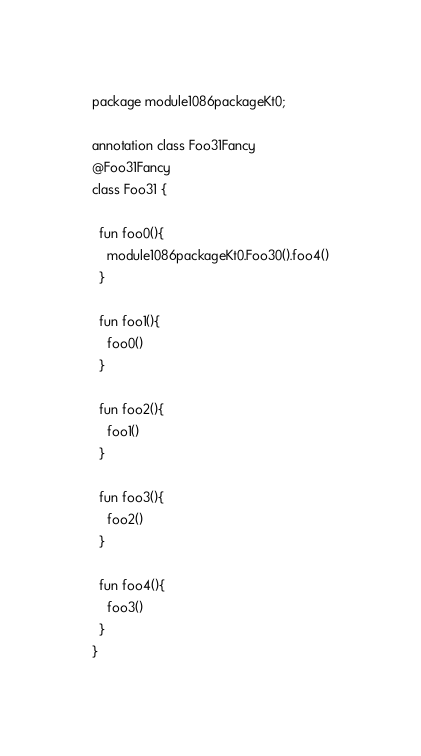<code> <loc_0><loc_0><loc_500><loc_500><_Kotlin_>package module1086packageKt0;

annotation class Foo31Fancy
@Foo31Fancy
class Foo31 {

  fun foo0(){
    module1086packageKt0.Foo30().foo4()
  }

  fun foo1(){
    foo0()
  }

  fun foo2(){
    foo1()
  }

  fun foo3(){
    foo2()
  }

  fun foo4(){
    foo3()
  }
}</code> 